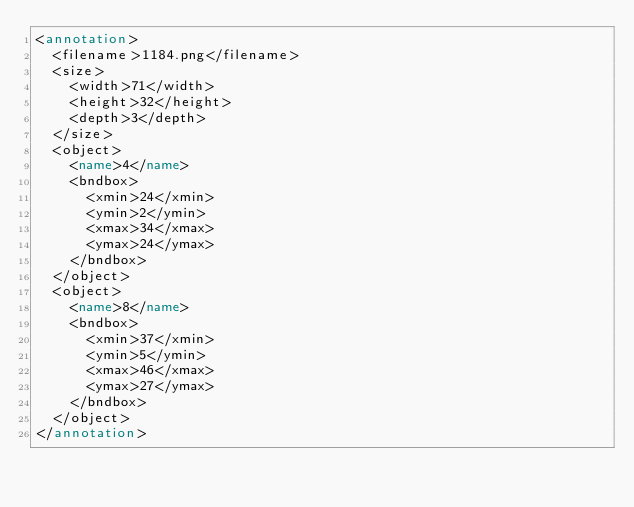Convert code to text. <code><loc_0><loc_0><loc_500><loc_500><_XML_><annotation>
  <filename>1184.png</filename>
  <size>
    <width>71</width>
    <height>32</height>
    <depth>3</depth>
  </size>
  <object>
    <name>4</name>
    <bndbox>
      <xmin>24</xmin>
      <ymin>2</ymin>
      <xmax>34</xmax>
      <ymax>24</ymax>
    </bndbox>
  </object>
  <object>
    <name>8</name>
    <bndbox>
      <xmin>37</xmin>
      <ymin>5</ymin>
      <xmax>46</xmax>
      <ymax>27</ymax>
    </bndbox>
  </object>
</annotation>
</code> 